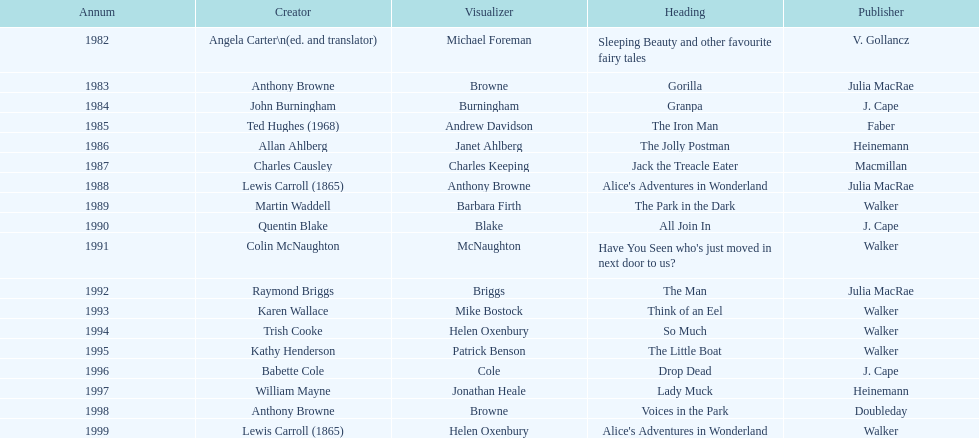What's the difference in years between angela carter's title and anthony browne's? 1. Help me parse the entirety of this table. {'header': ['Annum', 'Creator', 'Visualizer', 'Heading', 'Publisher'], 'rows': [['1982', 'Angela Carter\\n(ed. and translator)', 'Michael Foreman', 'Sleeping Beauty and other favourite fairy tales', 'V. Gollancz'], ['1983', 'Anthony Browne', 'Browne', 'Gorilla', 'Julia MacRae'], ['1984', 'John Burningham', 'Burningham', 'Granpa', 'J. Cape'], ['1985', 'Ted Hughes (1968)', 'Andrew Davidson', 'The Iron Man', 'Faber'], ['1986', 'Allan Ahlberg', 'Janet Ahlberg', 'The Jolly Postman', 'Heinemann'], ['1987', 'Charles Causley', 'Charles Keeping', 'Jack the Treacle Eater', 'Macmillan'], ['1988', 'Lewis Carroll (1865)', 'Anthony Browne', "Alice's Adventures in Wonderland", 'Julia MacRae'], ['1989', 'Martin Waddell', 'Barbara Firth', 'The Park in the Dark', 'Walker'], ['1990', 'Quentin Blake', 'Blake', 'All Join In', 'J. Cape'], ['1991', 'Colin McNaughton', 'McNaughton', "Have You Seen who's just moved in next door to us?", 'Walker'], ['1992', 'Raymond Briggs', 'Briggs', 'The Man', 'Julia MacRae'], ['1993', 'Karen Wallace', 'Mike Bostock', 'Think of an Eel', 'Walker'], ['1994', 'Trish Cooke', 'Helen Oxenbury', 'So Much', 'Walker'], ['1995', 'Kathy Henderson', 'Patrick Benson', 'The Little Boat', 'Walker'], ['1996', 'Babette Cole', 'Cole', 'Drop Dead', 'J. Cape'], ['1997', 'William Mayne', 'Jonathan Heale', 'Lady Muck', 'Heinemann'], ['1998', 'Anthony Browne', 'Browne', 'Voices in the Park', 'Doubleday'], ['1999', 'Lewis Carroll (1865)', 'Helen Oxenbury', "Alice's Adventures in Wonderland", 'Walker']]} 